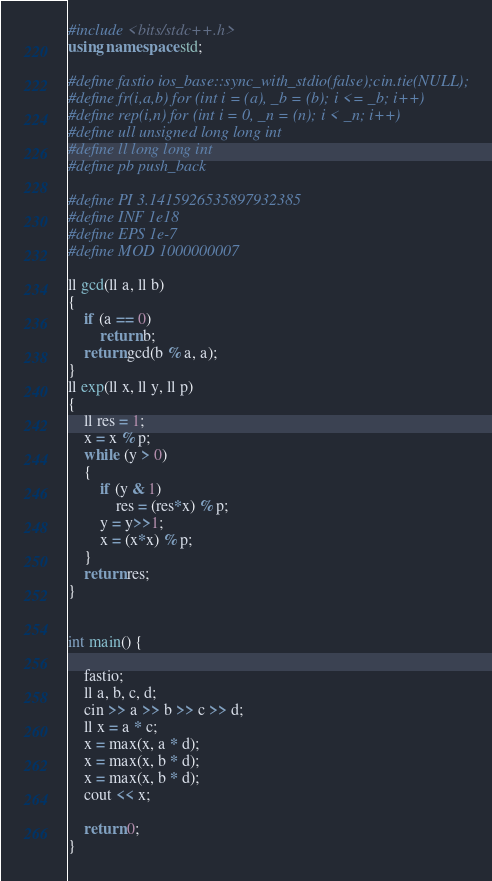Convert code to text. <code><loc_0><loc_0><loc_500><loc_500><_C++_>#include <bits/stdc++.h>
using namespace std;
 
#define fastio ios_base::sync_with_stdio(false);cin.tie(NULL);
#define fr(i,a,b) for (int i = (a), _b = (b); i <= _b; i++)
#define rep(i,n) for (int i = 0, _n = (n); i < _n; i++)
#define ull unsigned long long int
#define ll long long int
#define pb push_back
 
#define PI 3.1415926535897932385
#define INF 1e18
#define EPS 1e-7
#define MOD 1000000007 
                                 
ll gcd(ll a, ll b) 
{ 
    if (a == 0) 
        return b; 
    return gcd(b % a, a); 
} 
ll exp(ll x, ll y, ll p)
{
    ll res = 1;   
    x = x % p;  
    while (y > 0)
    {
        if (y & 1)    
            res = (res*x) % p;
        y = y>>1;     
        x = (x*x) % p; 
    }
    return res;
}

 
int main() {
   
    fastio;
    ll a, b, c, d;
    cin >> a >> b >> c >> d;
    ll x = a * c;
    x = max(x, a * d);
    x = max(x, b * d);
    x = max(x, b * d);
    cout << x;
 
    return 0; 
}</code> 